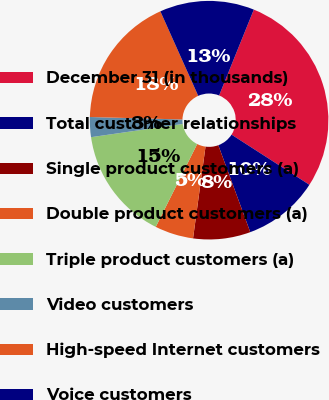<chart> <loc_0><loc_0><loc_500><loc_500><pie_chart><fcel>December 31 (in thousands)<fcel>Total customer relationships<fcel>Single product customers (a)<fcel>Double product customers (a)<fcel>Triple product customers (a)<fcel>Video customers<fcel>High-speed Internet customers<fcel>Voice customers<nl><fcel>28.0%<fcel>10.29%<fcel>7.76%<fcel>5.23%<fcel>15.35%<fcel>2.7%<fcel>17.88%<fcel>12.82%<nl></chart> 